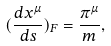Convert formula to latex. <formula><loc_0><loc_0><loc_500><loc_500>( \frac { d x ^ { \mu } } { d s } ) _ { F } = \frac { \pi ^ { \mu } } { m } ,</formula> 